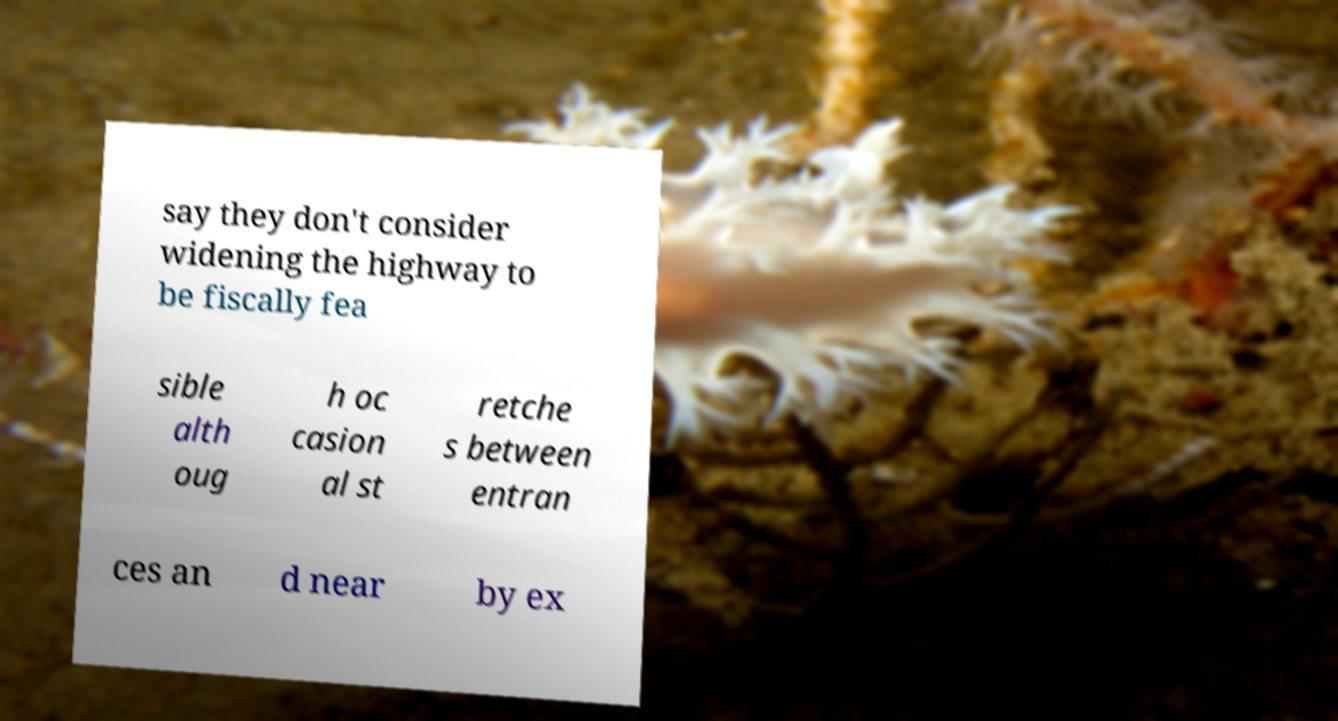Please read and relay the text visible in this image. What does it say? say they don't consider widening the highway to be fiscally fea sible alth oug h oc casion al st retche s between entran ces an d near by ex 